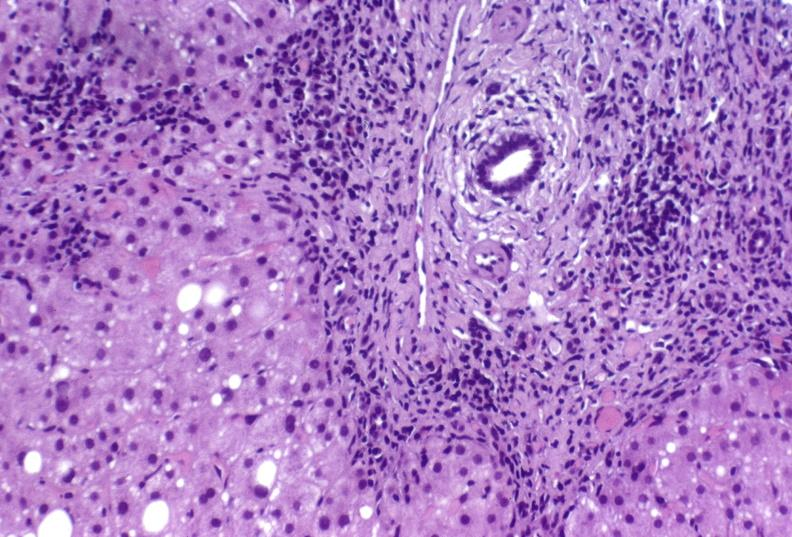s hepatobiliary present?
Answer the question using a single word or phrase. Yes 